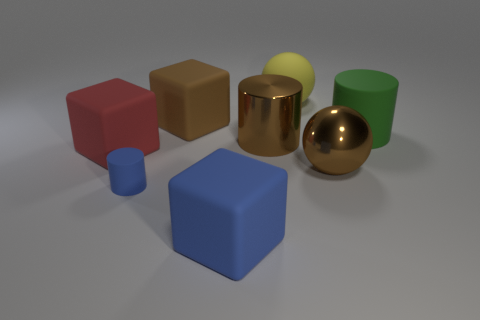Subtract all big metal cylinders. How many cylinders are left? 2 Subtract all green cylinders. How many cylinders are left? 2 Add 1 big blue objects. How many objects exist? 9 Subtract all blocks. How many objects are left? 5 Subtract 1 spheres. How many spheres are left? 1 Subtract all gray cylinders. How many blue cubes are left? 1 Add 7 large matte cylinders. How many large matte cylinders are left? 8 Add 5 large blue metal blocks. How many large blue metal blocks exist? 5 Subtract 0 cyan blocks. How many objects are left? 8 Subtract all purple balls. Subtract all blue cubes. How many balls are left? 2 